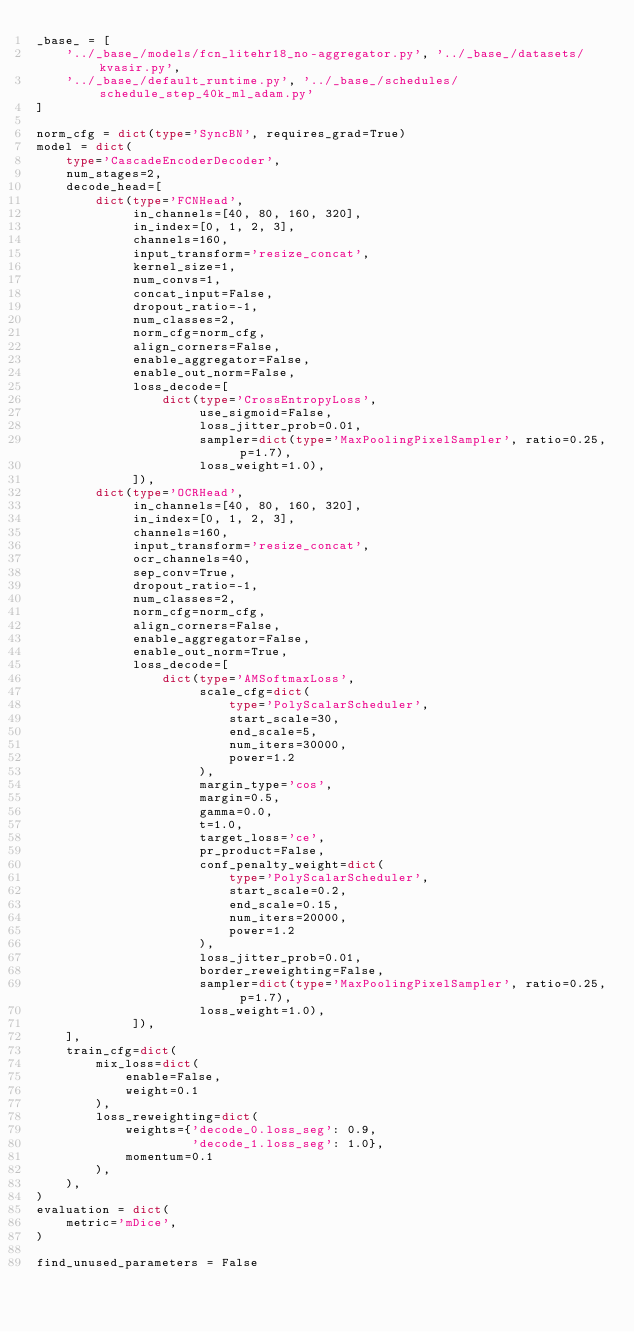Convert code to text. <code><loc_0><loc_0><loc_500><loc_500><_Python_>_base_ = [
    '../_base_/models/fcn_litehr18_no-aggregator.py', '../_base_/datasets/kvasir.py',
    '../_base_/default_runtime.py', '../_base_/schedules/schedule_step_40k_ml_adam.py'
]

norm_cfg = dict(type='SyncBN', requires_grad=True)
model = dict(
    type='CascadeEncoderDecoder',
    num_stages=2,
    decode_head=[
        dict(type='FCNHead',
             in_channels=[40, 80, 160, 320],
             in_index=[0, 1, 2, 3],
             channels=160,
             input_transform='resize_concat',
             kernel_size=1,
             num_convs=1,
             concat_input=False,
             dropout_ratio=-1,
             num_classes=2,
             norm_cfg=norm_cfg,
             align_corners=False,
             enable_aggregator=False,
             enable_out_norm=False,
             loss_decode=[
                 dict(type='CrossEntropyLoss',
                      use_sigmoid=False,
                      loss_jitter_prob=0.01,
                      sampler=dict(type='MaxPoolingPixelSampler', ratio=0.25, p=1.7),
                      loss_weight=1.0),
             ]),
        dict(type='OCRHead',
             in_channels=[40, 80, 160, 320],
             in_index=[0, 1, 2, 3],
             channels=160,
             input_transform='resize_concat',
             ocr_channels=40,
             sep_conv=True,
             dropout_ratio=-1,
             num_classes=2,
             norm_cfg=norm_cfg,
             align_corners=False,
             enable_aggregator=False,
             enable_out_norm=True,
             loss_decode=[
                 dict(type='AMSoftmaxLoss',
                      scale_cfg=dict(
                          type='PolyScalarScheduler',
                          start_scale=30,
                          end_scale=5,
                          num_iters=30000,
                          power=1.2
                      ),
                      margin_type='cos',
                      margin=0.5,
                      gamma=0.0,
                      t=1.0,
                      target_loss='ce',
                      pr_product=False,
                      conf_penalty_weight=dict(
                          type='PolyScalarScheduler',
                          start_scale=0.2,
                          end_scale=0.15,
                          num_iters=20000,
                          power=1.2
                      ),
                      loss_jitter_prob=0.01,
                      border_reweighting=False,
                      sampler=dict(type='MaxPoolingPixelSampler', ratio=0.25, p=1.7),
                      loss_weight=1.0),
             ]),
    ],
    train_cfg=dict(
        mix_loss=dict(
            enable=False,
            weight=0.1
        ),
        loss_reweighting=dict(
            weights={'decode_0.loss_seg': 0.9,
                     'decode_1.loss_seg': 1.0},
            momentum=0.1
        ),
    ),
)
evaluation = dict(
    metric='mDice',
)

find_unused_parameters = False
</code> 